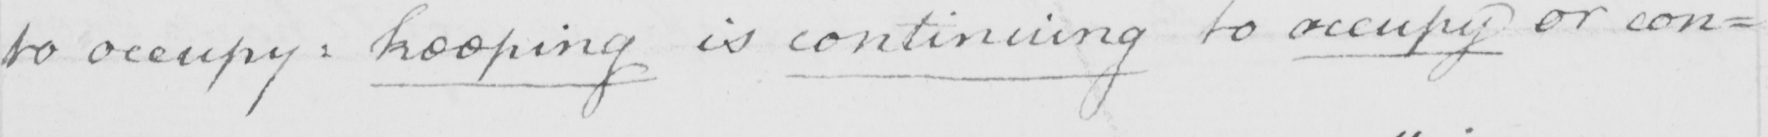What text is written in this handwritten line? to occupy :  keeping is continuing to occupy or con= 